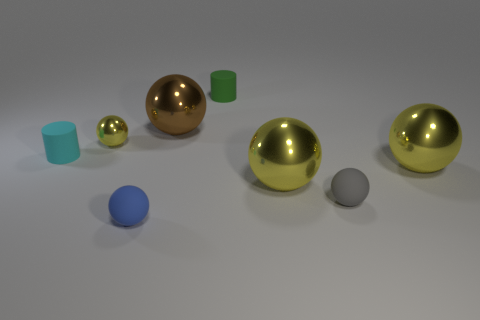How many yellow balls must be subtracted to get 1 yellow balls? 2 Subtract all green cylinders. How many yellow balls are left? 3 Subtract all brown spheres. How many spheres are left? 5 Subtract all big yellow spheres. How many spheres are left? 4 Subtract all brown spheres. Subtract all cyan cylinders. How many spheres are left? 5 Add 2 small green shiny balls. How many objects exist? 10 Subtract all cylinders. How many objects are left? 6 Add 7 gray rubber balls. How many gray rubber balls are left? 8 Add 5 brown metal spheres. How many brown metal spheres exist? 6 Subtract 0 cyan blocks. How many objects are left? 8 